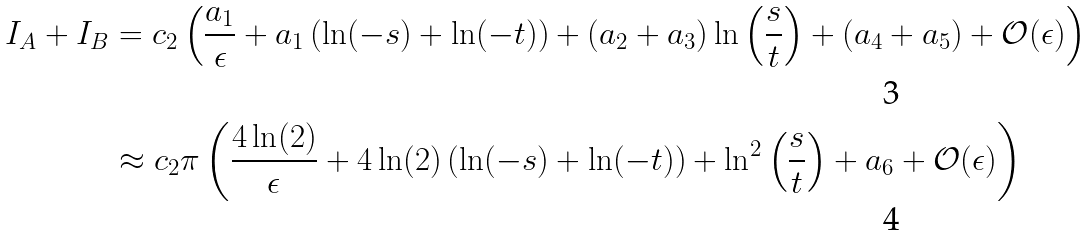<formula> <loc_0><loc_0><loc_500><loc_500>I _ { A } + I _ { B } & = c _ { 2 } \left ( \frac { a _ { 1 } } { \epsilon } + a _ { 1 } \left ( \ln ( - s ) + \ln ( - t ) \right ) + ( a _ { 2 } + a _ { 3 } ) \ln \left ( \frac { s } { t } \right ) + ( a _ { 4 } + a _ { 5 } ) + \mathcal { O } ( \epsilon ) \right ) \\ & \approx c _ { 2 } \pi \left ( \frac { 4 \ln ( 2 ) } { \epsilon } + 4 \ln ( 2 ) \left ( \ln ( - s ) + \ln ( - t ) \right ) + \ln ^ { 2 } \left ( \frac { s } { t } \right ) + a _ { 6 } + \mathcal { O } ( \epsilon ) \right )</formula> 